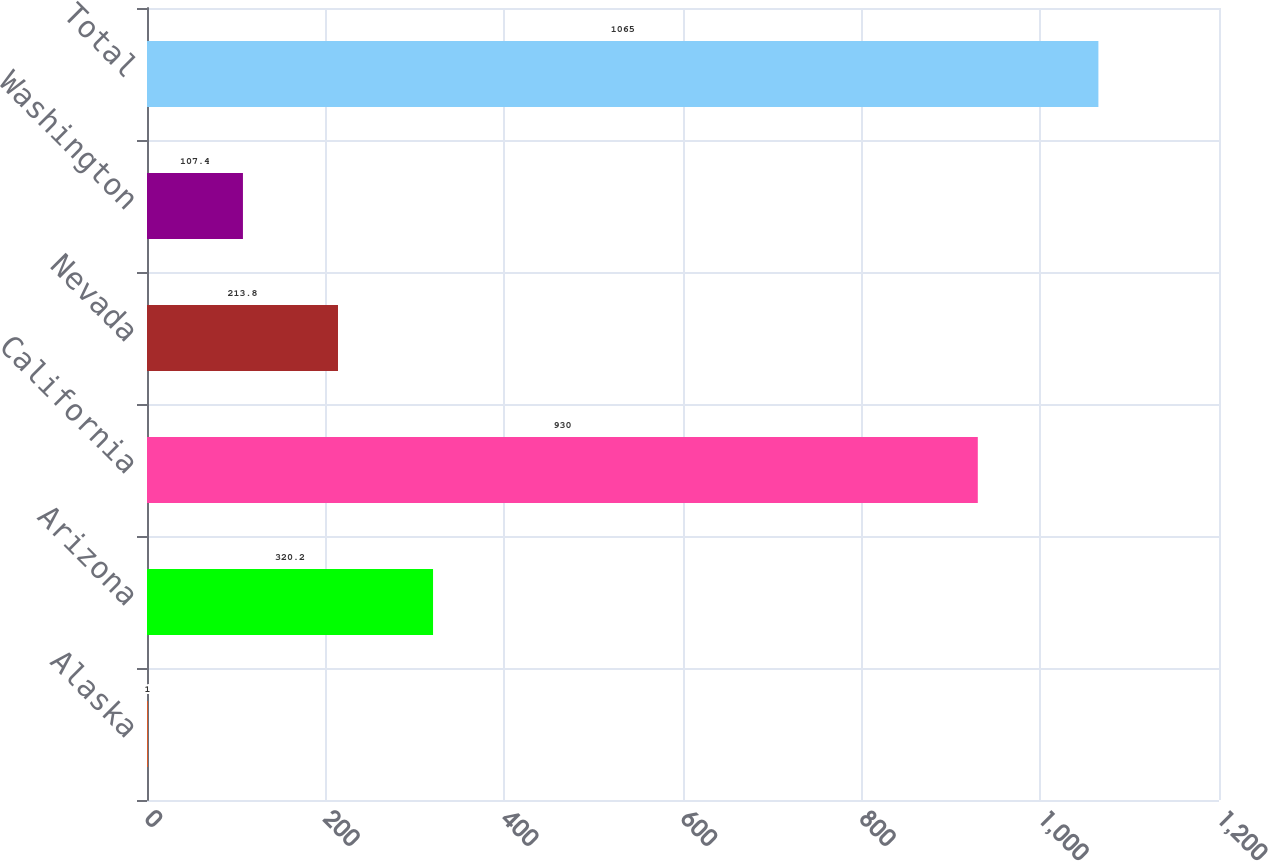Convert chart. <chart><loc_0><loc_0><loc_500><loc_500><bar_chart><fcel>Alaska<fcel>Arizona<fcel>California<fcel>Nevada<fcel>Washington<fcel>Total<nl><fcel>1<fcel>320.2<fcel>930<fcel>213.8<fcel>107.4<fcel>1065<nl></chart> 